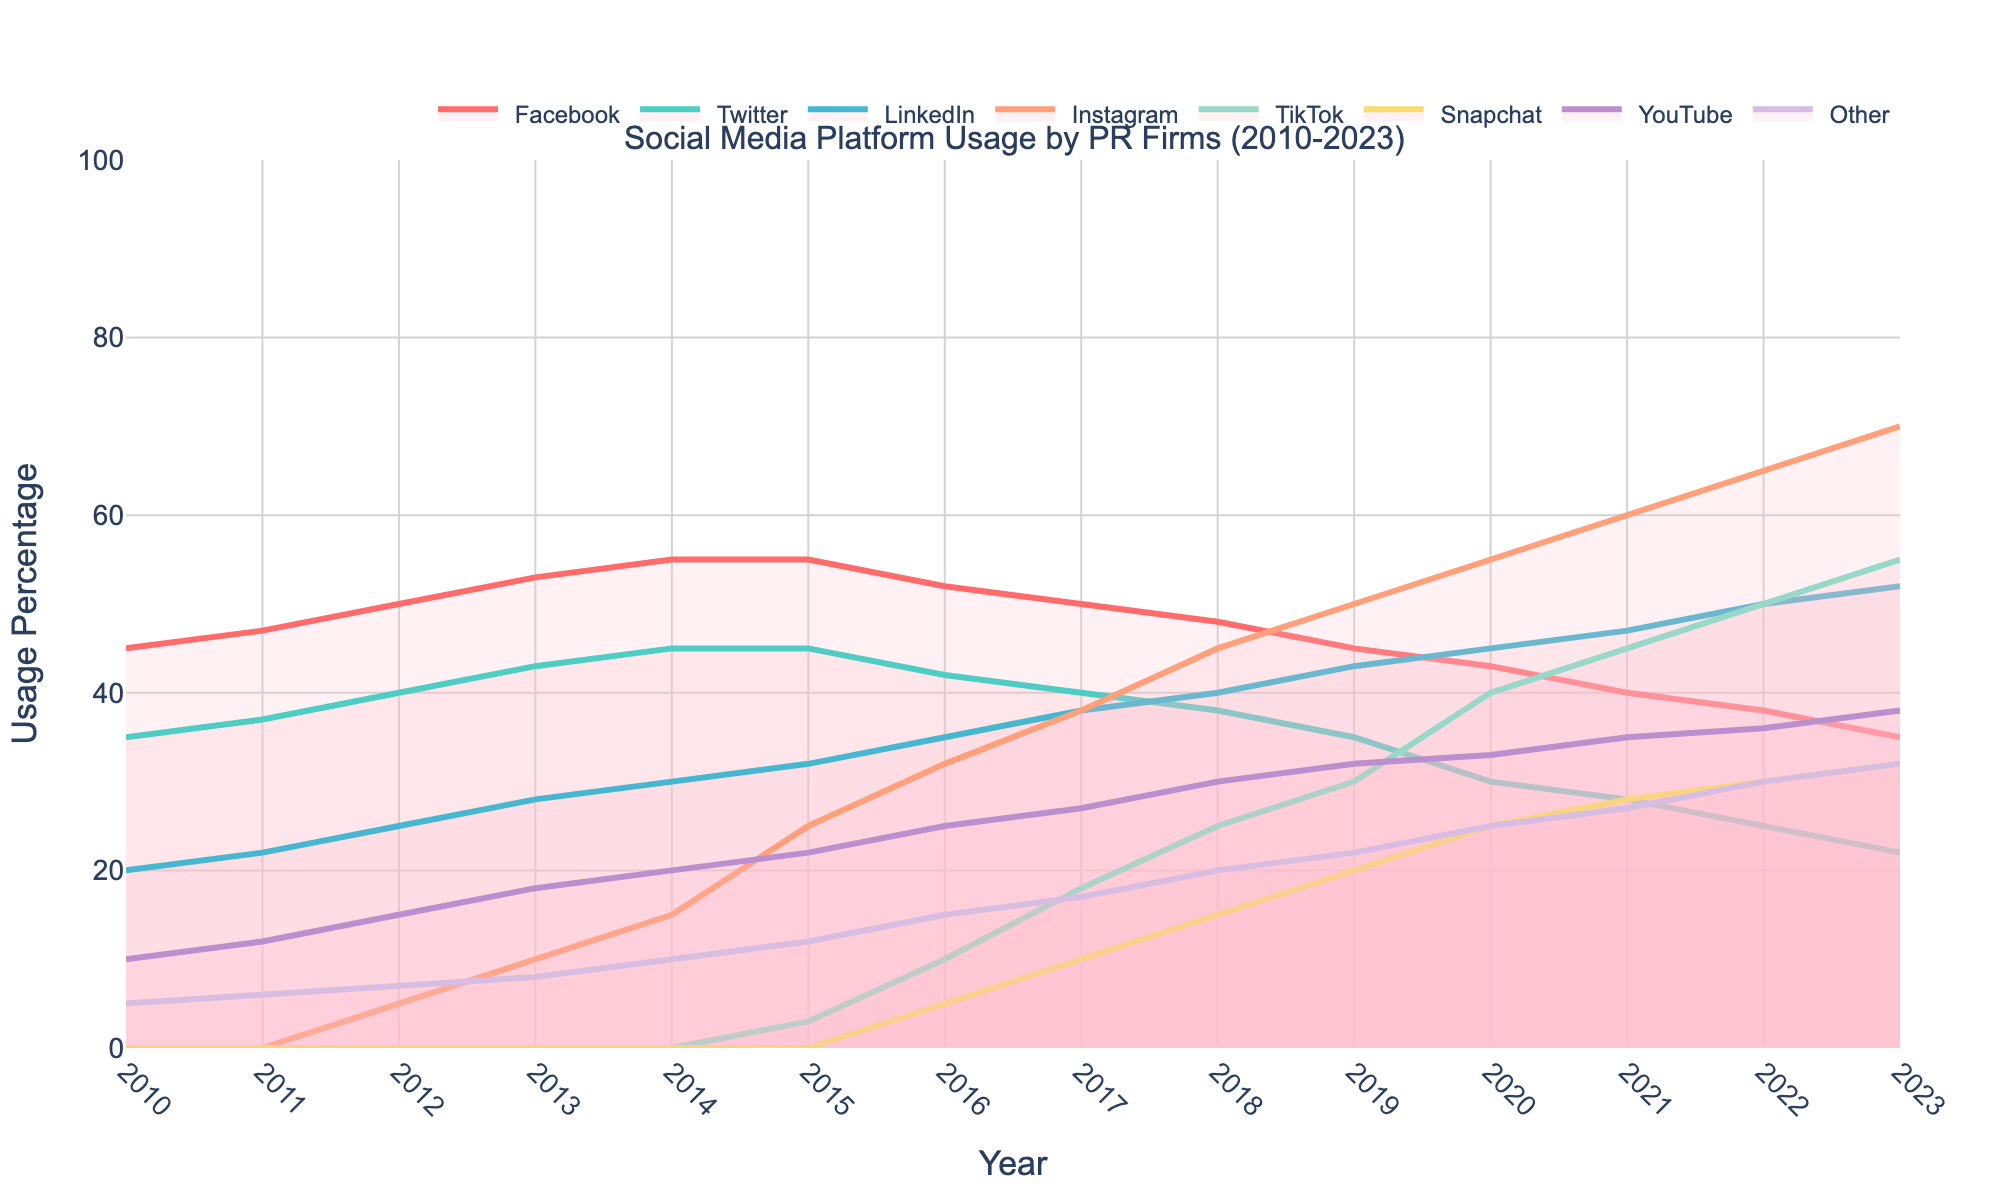What's the highest usage percentage of Facebook and in which year? The highest usage percentage on the figure can be identified as the peak point in the line corresponding to Facebook. This peak is at the topmost point of the line. Specifically, for Facebook, the highest point is in the year 2014 at 55%.
Answer: 55% in 2014 Which social media platform shows a continuously increasing trend from 2010 to 2023? A continuously increasing trend can be seen by a line that goes upwards consistently without any dips. TikTok's line starts at 0% in 2010 and keeps increasing until it reaches 55% in 2023, indicating a continuous rise.
Answer: TikTok In what year did Instagram's usage surpass Twitter's usage? To determine when Instagram's usage surpassed Twitter's, look for where Instagram's line crosses above Twitter's line. This intersection point first happens in 2016, where Instagram has a usage percentage of 32% while Twitter has 42%, and in 2017, Instagram has 38% while Twitter has 40%, It's in 2018 that Instagram has 45% and Twitter drops to 38%, clearly surpassing it.
Answer: 2018 Compare the usage percentage of LinkedIn and YouTube in 2023. Which platform is used more, and by how much? Look at the 2023 data points for both LinkedIn and YouTube and subtract the lesser value from the greater one. In 2023, LinkedIn has 52% while YouTube has 38%, so LinkedIn is used more and the difference is 52% - 38% = 14%.
Answer: LinkedIn, by 14% What is the average usage percentage of Twitter over the years 2010-2023? Sum all the usage percentages of Twitter from 2010 to 2023 and then divide by the number of years. The sum is (35 + 37 + 40 + 43 + 45 + 45 + 42 + 40 + 38 + 35 + 30 + 28 + 25 + 22) = 465. The number of years is 14. Therefore, the average is 465 / 14 ≈ 33.21%.
Answer: 33.21% Which platform had a 0% usage in 2010 but showed a significant increase by 2023? By looking at the starting point in 2010, and then checking for any platform that started at 0%, identify which has significant numbers by 2023. Both TikTok and Snapchat had 0% usage in 2010, but out of these, by 2023 TikTok (55%) shows a more significant increase compared to Snapchat (32%).
Answer: TikTok What is the combined usage of all platforms in the year 2015? Add up the usage percentages of all platforms in 2015. The combined usage is 55 (Facebook) + 45 (Twitter) + 32 (LinkedIn) + 25 (Instagram) + 3 (TikTok) + 0 (Snapchat) + 22 (YouTube) + 12 (Other) = 194%.
Answer: 194% Identify and explain any consistent decline trend for any platform from 2010 to 2023. For a decline trend, look for consistently decreasing values. Facebook shows a declining trend from 2016 (52%) to 2023 (35%), moving down each subsequent year without any increase, indicating a steady decline.
Answer: Facebook When did YouTube's usage first exceed 30%? Check the years when YouTube's usage reaches and surpasses the 30% mark. The line representing YouTube first crosses the 30% mark in 2018.
Answer: 2018 